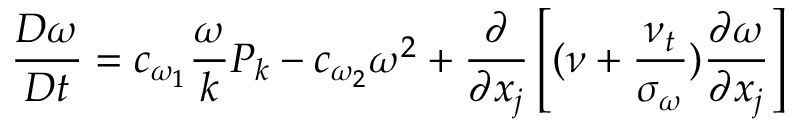<formula> <loc_0><loc_0><loc_500><loc_500>{ \frac { D \omega } { D t } } = c _ { \omega _ { 1 } } { \frac { \omega } { k } } P _ { k } - c _ { \omega _ { 2 } } \omega ^ { 2 } + { \frac { \partial } { \partial x _ { j } } } \left [ ( \nu + { \frac { \nu _ { t } } { \sigma _ { \omega } } } ) { \frac { \partial \omega } { \partial x _ { j } } } \right ]</formula> 